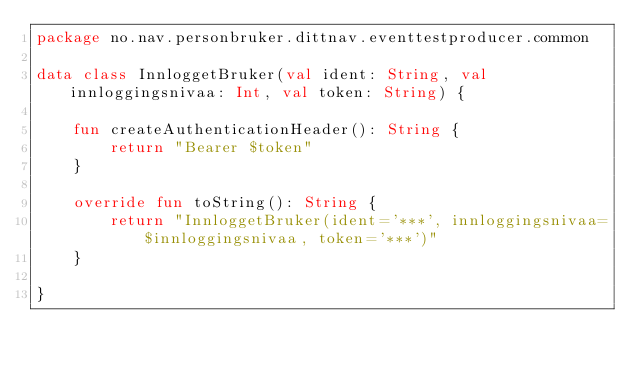Convert code to text. <code><loc_0><loc_0><loc_500><loc_500><_Kotlin_>package no.nav.personbruker.dittnav.eventtestproducer.common

data class InnloggetBruker(val ident: String, val innloggingsnivaa: Int, val token: String) {

    fun createAuthenticationHeader(): String {
        return "Bearer $token"
    }

    override fun toString(): String {
        return "InnloggetBruker(ident='***', innloggingsnivaa=$innloggingsnivaa, token='***')"
    }

}
</code> 